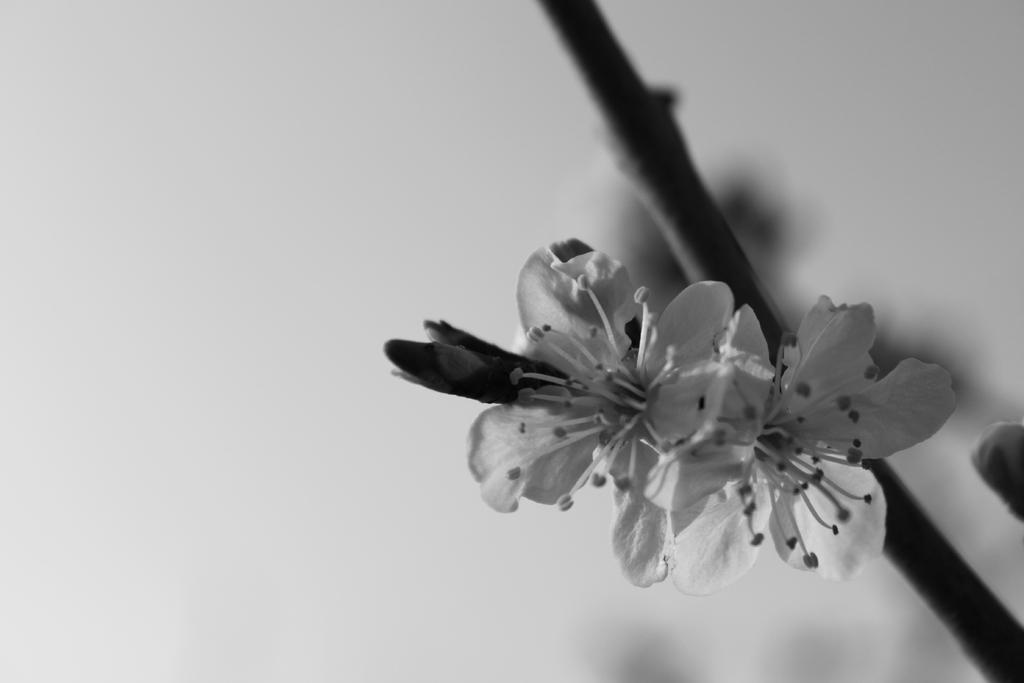What is the color scheme of the image? The image is black and white. What type of plants can be seen in the image? There are flowers in the image. Can you describe the stage of growth of one of the flowers? There is a flower bud in the image. What color is the background of the image? The background of the image is white. What type of church can be seen in the image? There is no church present in the image; it features flowers and a flower bud. What is the title of the image? The image does not have a title, as it is a photograph or illustration without accompanying text. 